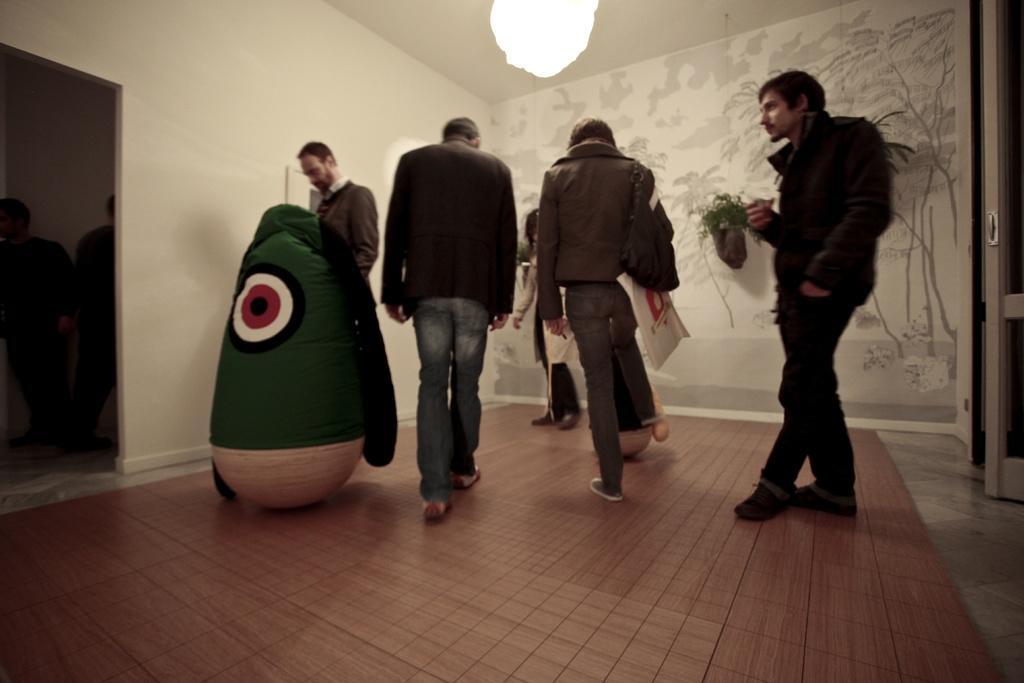How would you summarize this image in a sentence or two? In this image I can see the group of people and the toys. In the background I can see the flower pots to the wall. I can see the light at the top. 